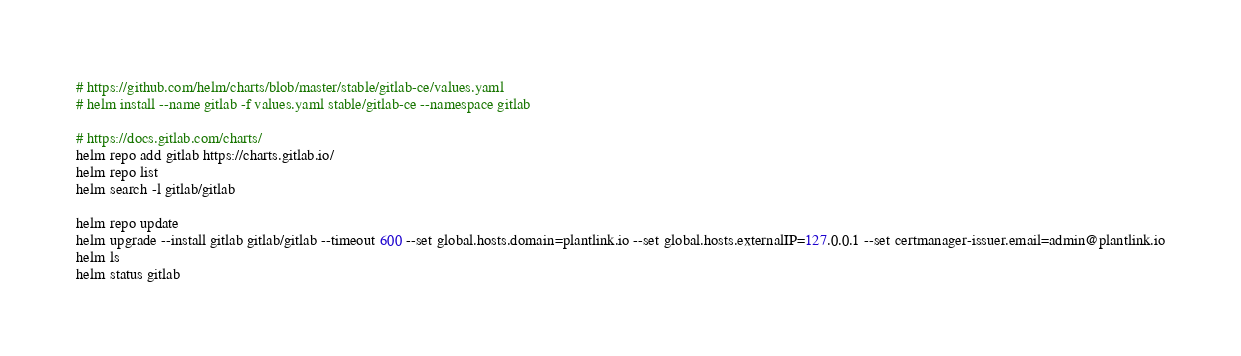Convert code to text. <code><loc_0><loc_0><loc_500><loc_500><_Bash_># https://github.com/helm/charts/blob/master/stable/gitlab-ce/values.yaml
# helm install --name gitlab -f values.yaml stable/gitlab-ce --namespace gitlab

# https://docs.gitlab.com/charts/
helm repo add gitlab https://charts.gitlab.io/
helm repo list
helm search -l gitlab/gitlab

helm repo update
helm upgrade --install gitlab gitlab/gitlab --timeout 600 --set global.hosts.domain=plantlink.io --set global.hosts.externalIP=127.0.0.1 --set certmanager-issuer.email=admin@plantlink.io
helm ls
helm status gitlab</code> 